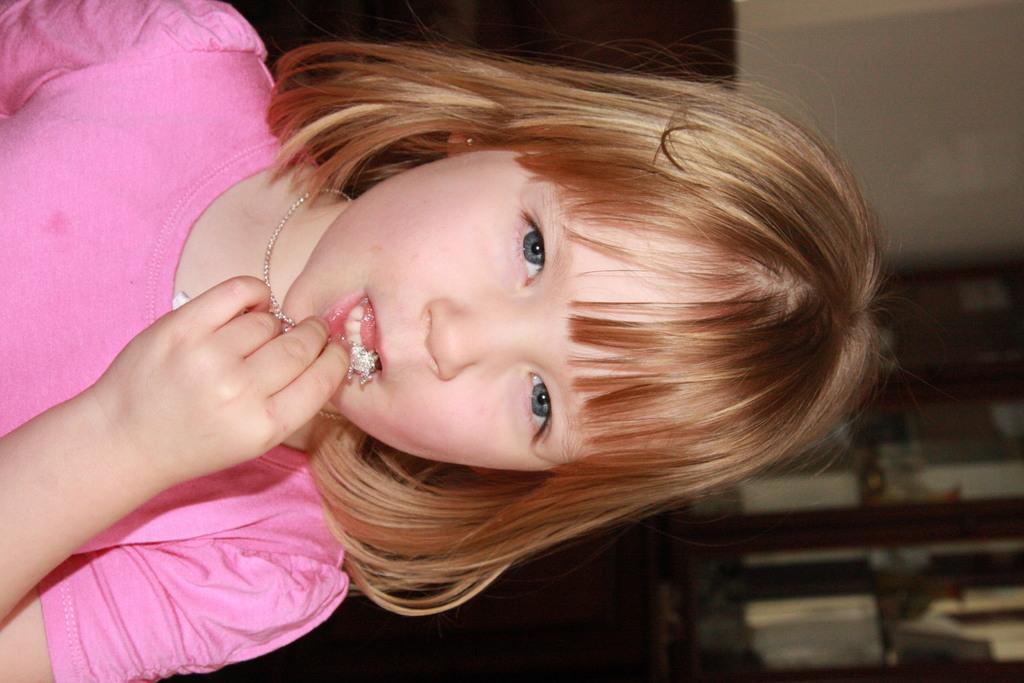Who is the main subject in the image? There is a girl in the image. What is the girl wearing? The girl is wearing a pink dress. Can you describe the background of the image? The background of the image is blurred. Where is the nest located in the image? There is no nest present in the image. Can you describe the man in the image? There is no man present in the image. 